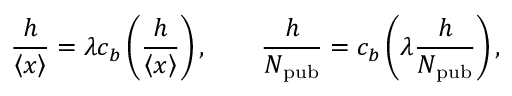Convert formula to latex. <formula><loc_0><loc_0><loc_500><loc_500>\frac { h } { \left \langle { x } \right \rangle } = \lambda c _ { b } \left ( \frac { h } { \left \langle { x } \right \rangle } \right ) , \quad \frac { h } { N _ { p u b } } = c _ { b } \left ( \lambda \frac { h } { N _ { p u b } } \right ) ,</formula> 